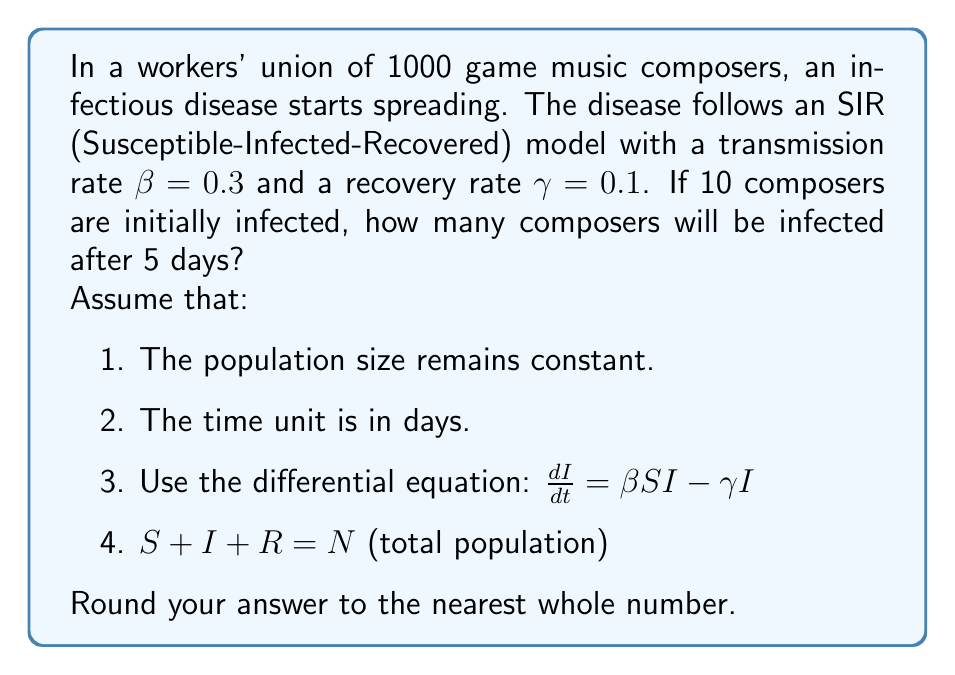Teach me how to tackle this problem. To solve this problem, we'll use the SIR model differential equation for the rate of change in infected individuals:

$$\frac{dI}{dt} = \beta SI - \gamma I$$

Where:
- $S$ is the number of susceptible individuals
- $I$ is the number of infected individuals
- $\beta$ is the transmission rate
- $\gamma$ is the recovery rate

We're given:
- Total population $N = 1000$
- Initial infected $I_0 = 10$
- $\beta = 0.3$
- $\gamma = 0.1$
- Time $t = 5$ days

Step 1: Calculate the initial number of susceptible individuals:
$S_0 = N - I_0 = 1000 - 10 = 990$

Step 2: Use the approximation method to solve the differential equation:
$$I_{t+1} = I_t + (\beta S_t I_t - \gamma I_t) \Delta t$$

Where $\Delta t$ is the time step. We'll use $\Delta t = 1$ day for simplicity.

Step 3: Calculate the number of infected individuals for each day:

Day 0: $I_0 = 10$
Day 1: $I_1 = 10 + (0.3 * 990 * 10 - 0.1 * 10) * 1 = 307$
Day 2: $I_2 = 307 + (0.3 * 693 * 307 - 0.1 * 307) * 1 = 619$
Day 3: $I_3 = 619 + (0.3 * 381 * 619 - 0.1 * 619) * 1 = 688$
Day 4: $I_4 = 688 + (0.3 * 312 * 688 - 0.1 * 688) * 1 = 632$
Day 5: $I_5 = 632 + (0.3 * 368 * 632 - 0.1 * 632) * 1 = 545$

Step 4: Round the final result to the nearest whole number.
Answer: 545 composers will be infected after 5 days. 